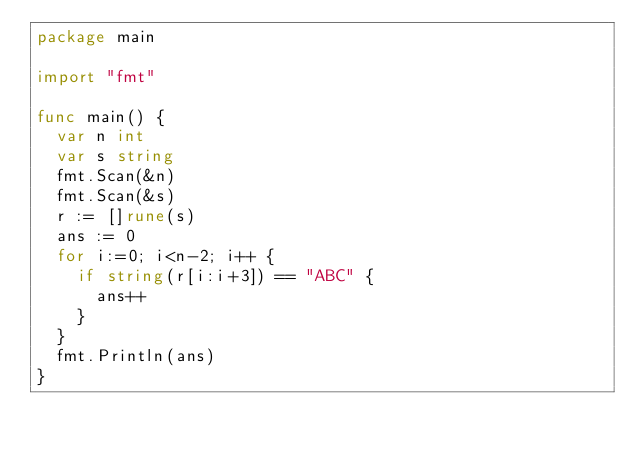Convert code to text. <code><loc_0><loc_0><loc_500><loc_500><_Go_>package main

import "fmt"

func main() {
	var n int
	var s string
	fmt.Scan(&n)
	fmt.Scan(&s)
	r := []rune(s)
	ans := 0
	for i:=0; i<n-2; i++ {
		if string(r[i:i+3]) == "ABC" {
			ans++
		}
	}
	fmt.Println(ans)
}</code> 